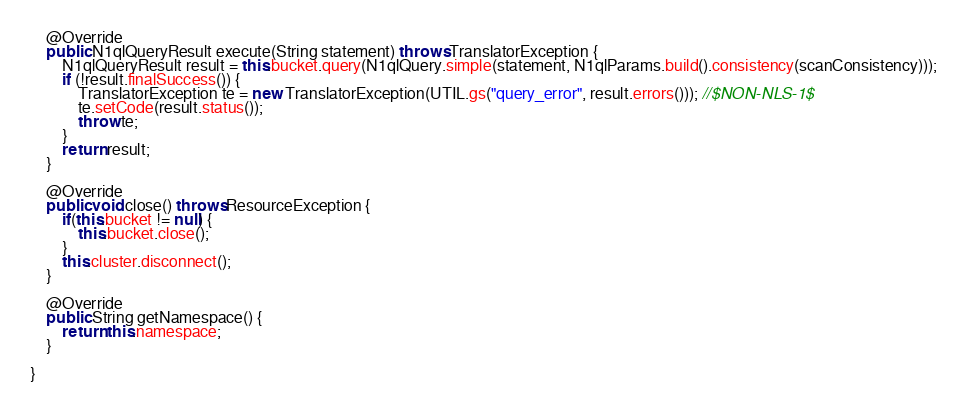<code> <loc_0><loc_0><loc_500><loc_500><_Java_>    @Override
    public N1qlQueryResult execute(String statement) throws TranslatorException {
        N1qlQueryResult result = this.bucket.query(N1qlQuery.simple(statement, N1qlParams.build().consistency(scanConsistency)));
        if (!result.finalSuccess()) {
            TranslatorException te = new TranslatorException(UTIL.gs("query_error", result.errors())); //$NON-NLS-1$
            te.setCode(result.status());
            throw te;
        }
        return result;
    }
    
    @Override
    public void close() throws ResourceException {
        if(this.bucket != null) {
            this.bucket.close();
        }
        this.cluster.disconnect();
    }

    @Override
    public String getNamespace() {
        return this.namespace;
    }

}
</code> 